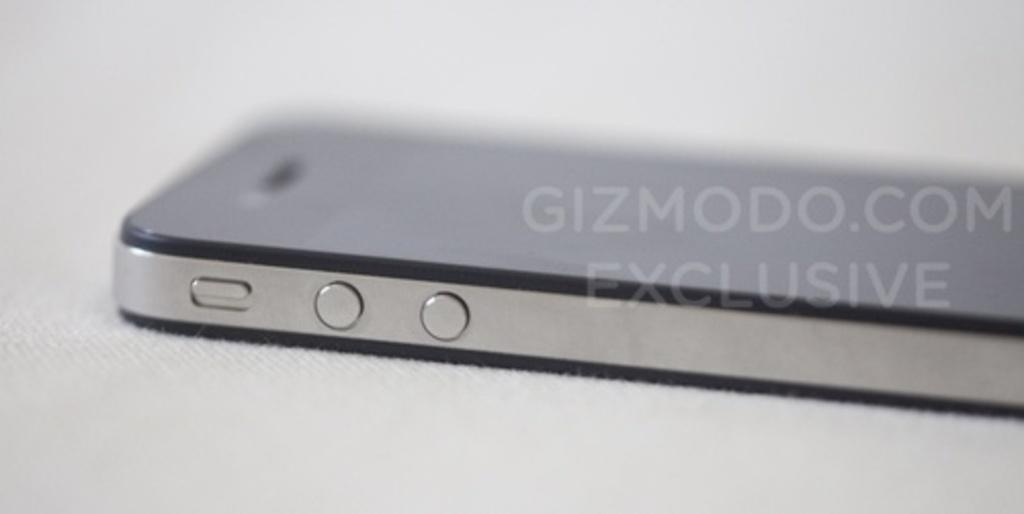What is the text of the watermark over the phone?
Ensure brevity in your answer.  Gizmodo.com exclusive. 